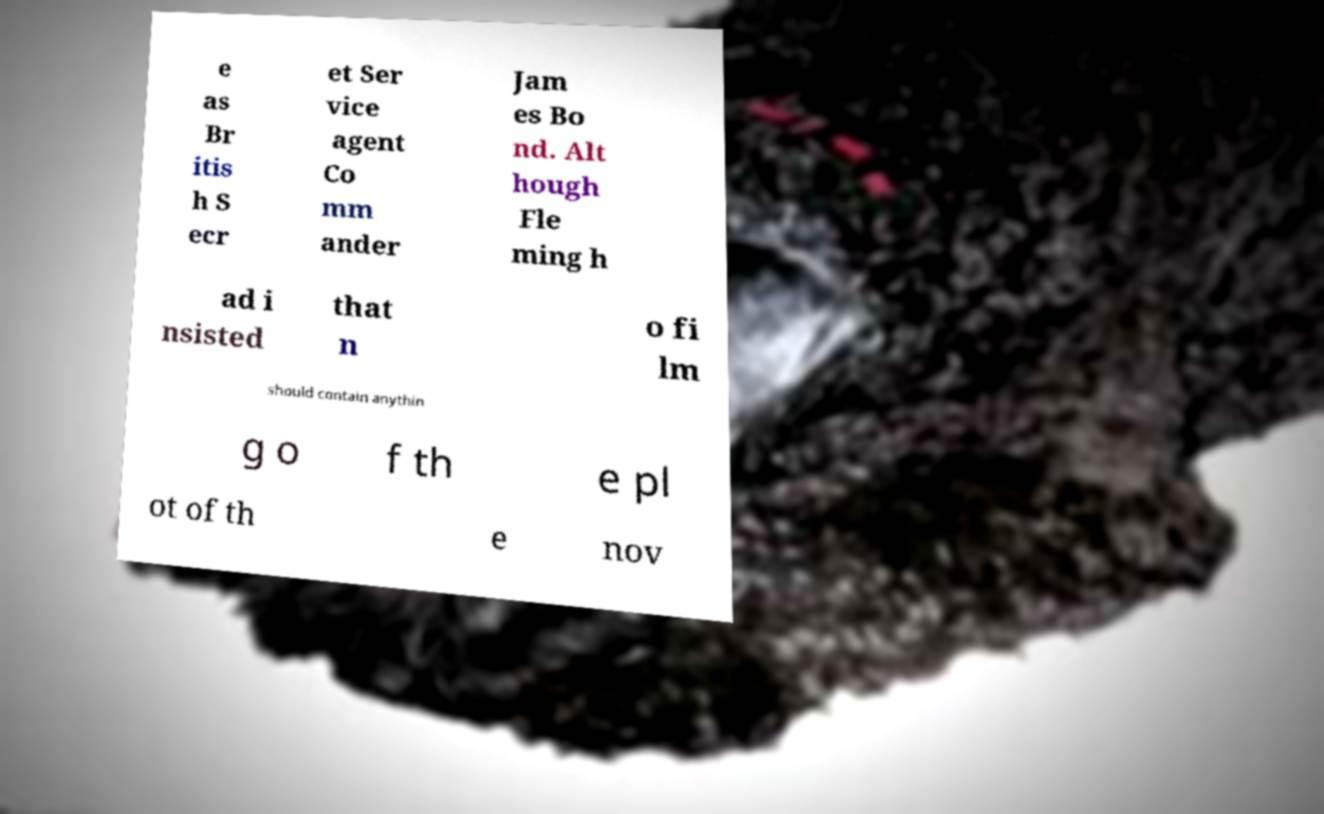What messages or text are displayed in this image? I need them in a readable, typed format. e as Br itis h S ecr et Ser vice agent Co mm ander Jam es Bo nd. Alt hough Fle ming h ad i nsisted that n o fi lm should contain anythin g o f th e pl ot of th e nov 